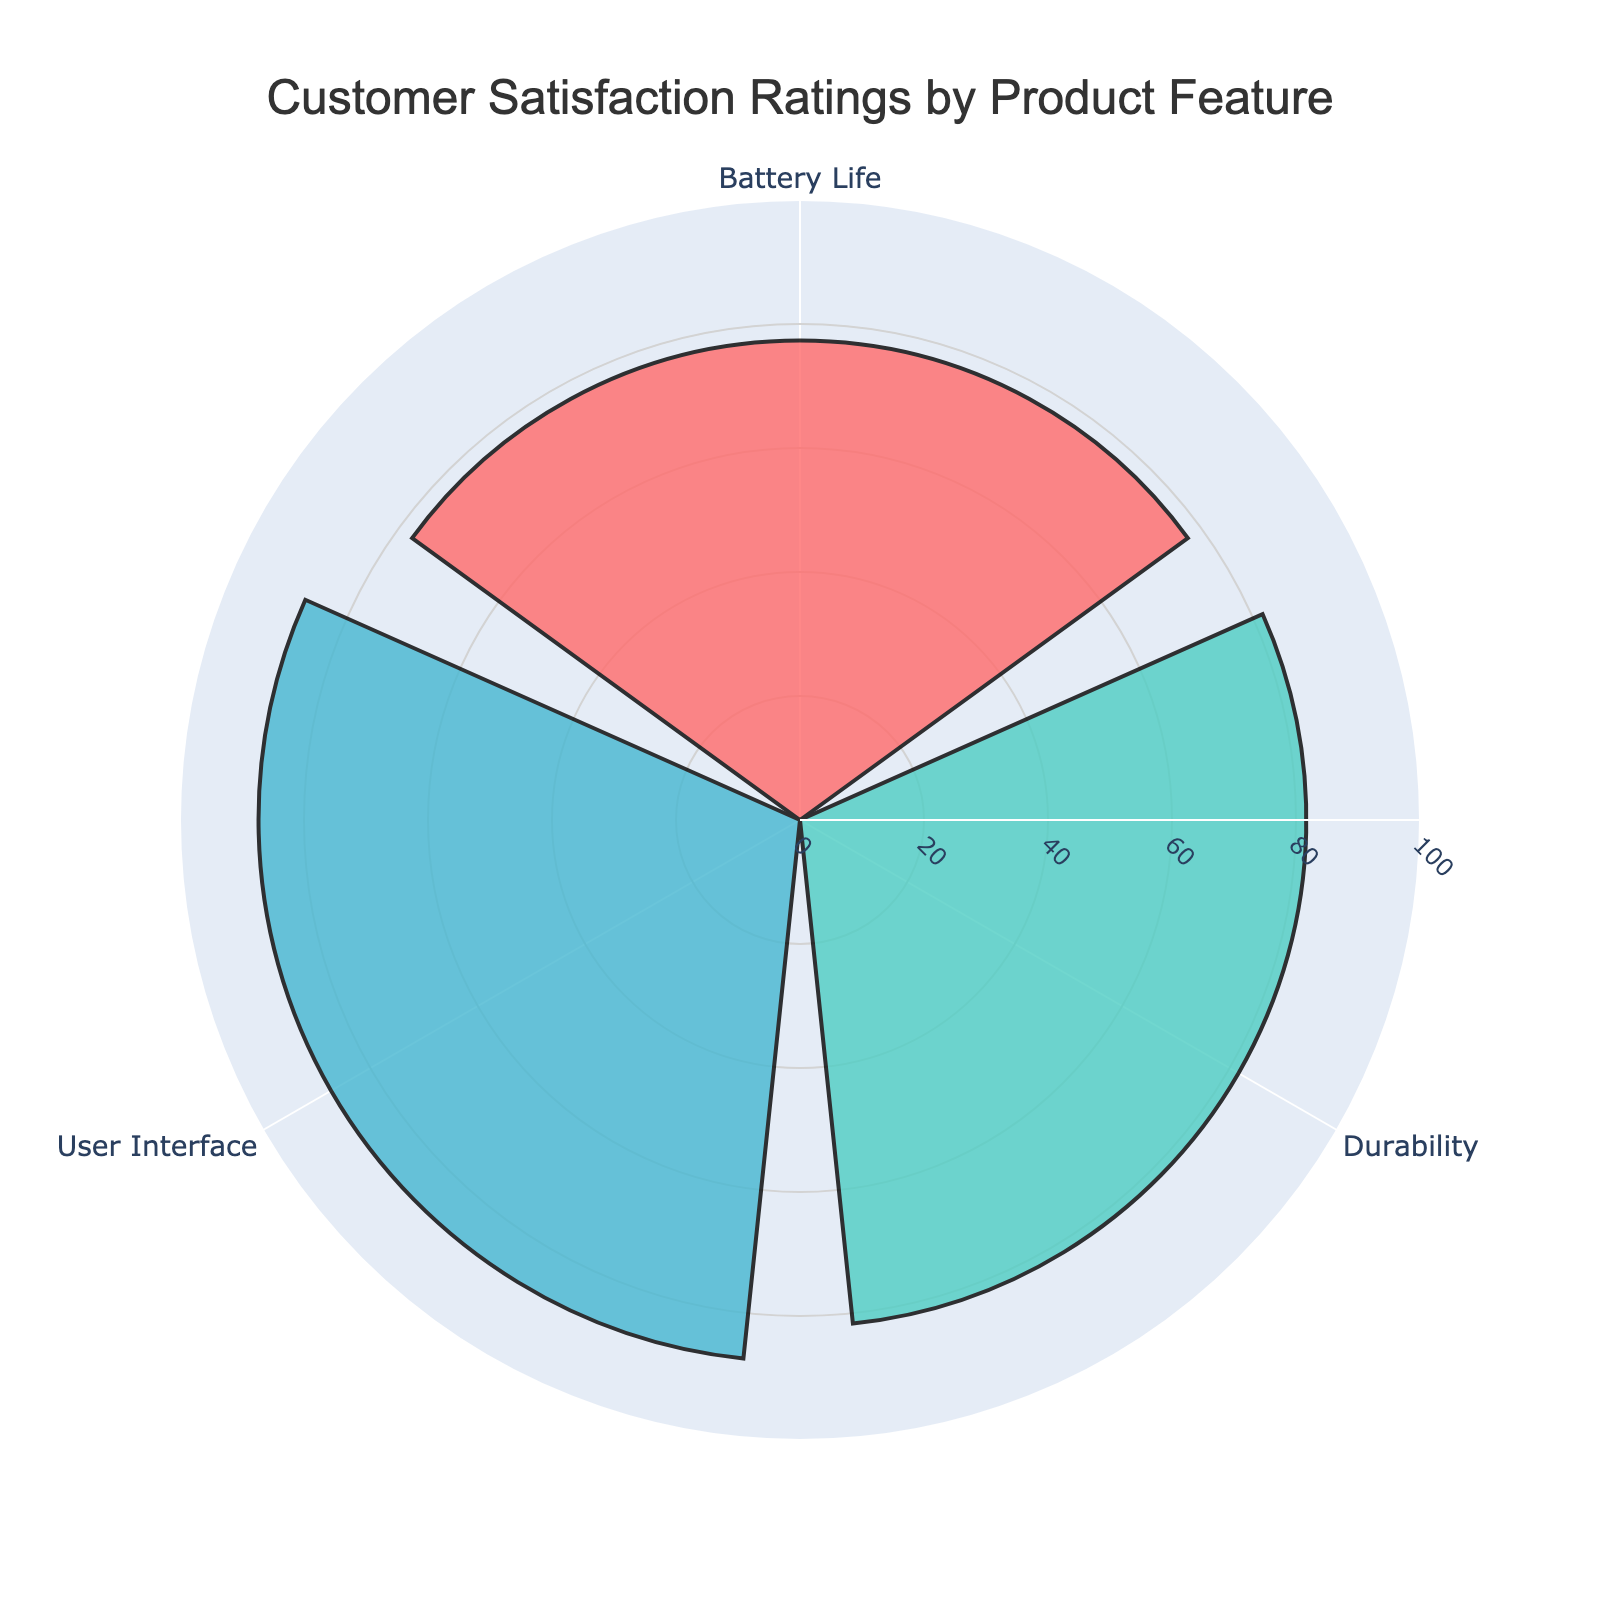How many customer satisfaction ratings are depicted for each product feature? Each product feature has one bar representing the average customer satisfaction rating, as the rose chart summarizes the group average.
Answer: One rating per feature What is the title of the chart? The title is displayed at the top of the chart within the layout.
Answer: "Customer Satisfaction Ratings by Product Feature" Which product feature has the highest customer satisfaction rating? By comparing the bar lengths, the 'User Interface' feature has the highest rating.
Answer: User Interface What is the average customer satisfaction rating across all product features? First, find the mean ratings from the rose chart: Durability (81.67), User Interface (87.33), Battery Life (77.33). Average is (81.67 + 87.33 + 77.33) / 3.
Answer: 82.11 How much higher is the user interface rating compared to battery life? User Interface is 87.33, Battery Life is 77.33. Difference = 87.33 - 77.33.
Answer: 10 What color represents the 'Durability' feature? The color of the bar for 'Durability' can be identified visually in the chart.
Answer: Red Which feature has the smallest customer satisfaction rating? By comparing the bar lengths, the 'Battery Life' feature has the smallest rating.
Answer: Battery Life Compare the ratings of 'Durability' and 'User Interface', which is greater? 'User Interface' rating (87.33) is greater than 'Durability' rating (81.67).
Answer: User Interface Is there any product feature with a customer satisfaction rating below 80? The 'Battery Life' feature has a rating below 80, specifically 77.33.
Answer: Yes What is the combined customer satisfaction rating for 'Durability' and 'User Interface'? Add the ratings for 'Durability' (81.67) and 'User Interface' (87.33).
Answer: 169 